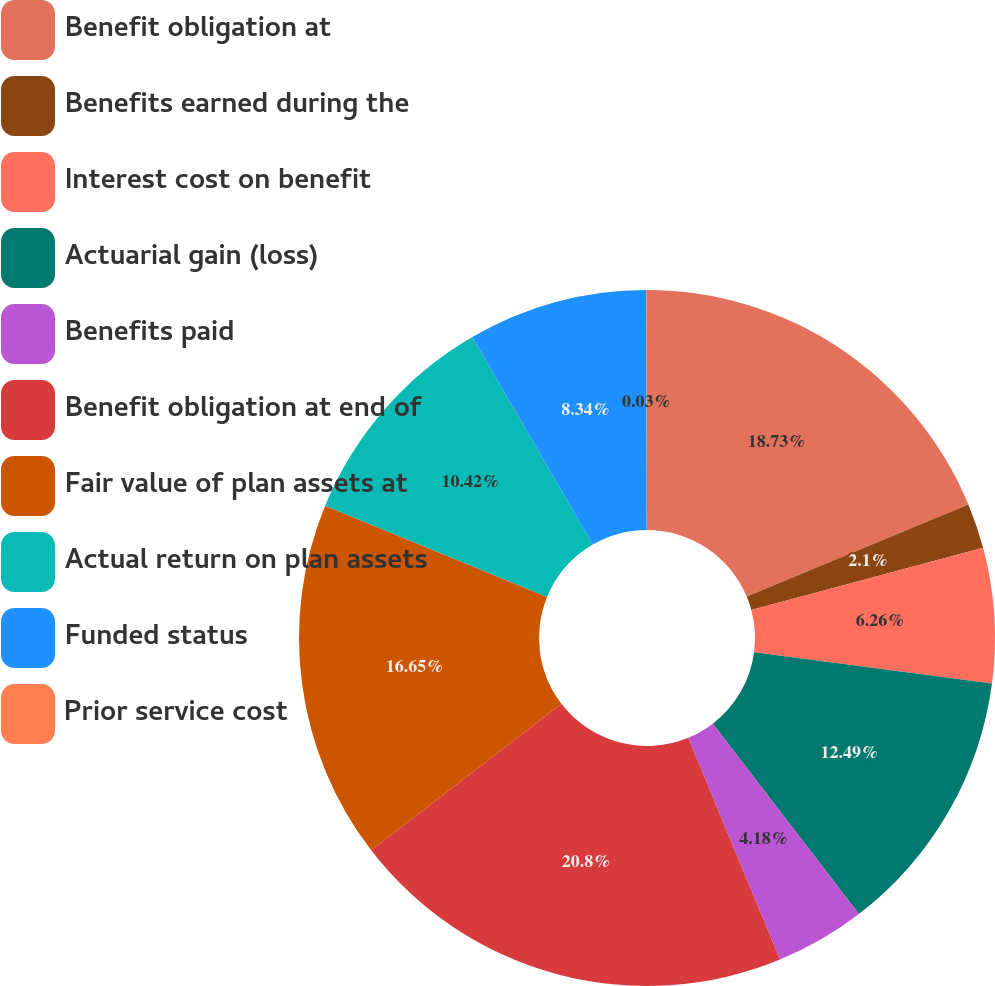Convert chart. <chart><loc_0><loc_0><loc_500><loc_500><pie_chart><fcel>Benefit obligation at<fcel>Benefits earned during the<fcel>Interest cost on benefit<fcel>Actuarial gain (loss)<fcel>Benefits paid<fcel>Benefit obligation at end of<fcel>Fair value of plan assets at<fcel>Actual return on plan assets<fcel>Funded status<fcel>Prior service cost<nl><fcel>18.73%<fcel>2.1%<fcel>6.26%<fcel>12.49%<fcel>4.18%<fcel>20.8%<fcel>16.65%<fcel>10.42%<fcel>8.34%<fcel>0.03%<nl></chart> 